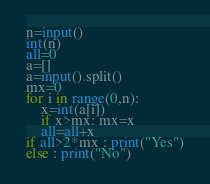<code> <loc_0><loc_0><loc_500><loc_500><_Python_>n=input()
int(n)
all=0
a=[]
a=input().split()
mx=0
for i in range(0,n):
	x=int(a[i])
	if x>mx: mx=x
	all=all+x
if all>2*mx : print("Yes")
else : print("No")</code> 